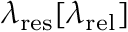Convert formula to latex. <formula><loc_0><loc_0><loc_500><loc_500>\lambda _ { r e s } [ \lambda _ { r e l } ]</formula> 